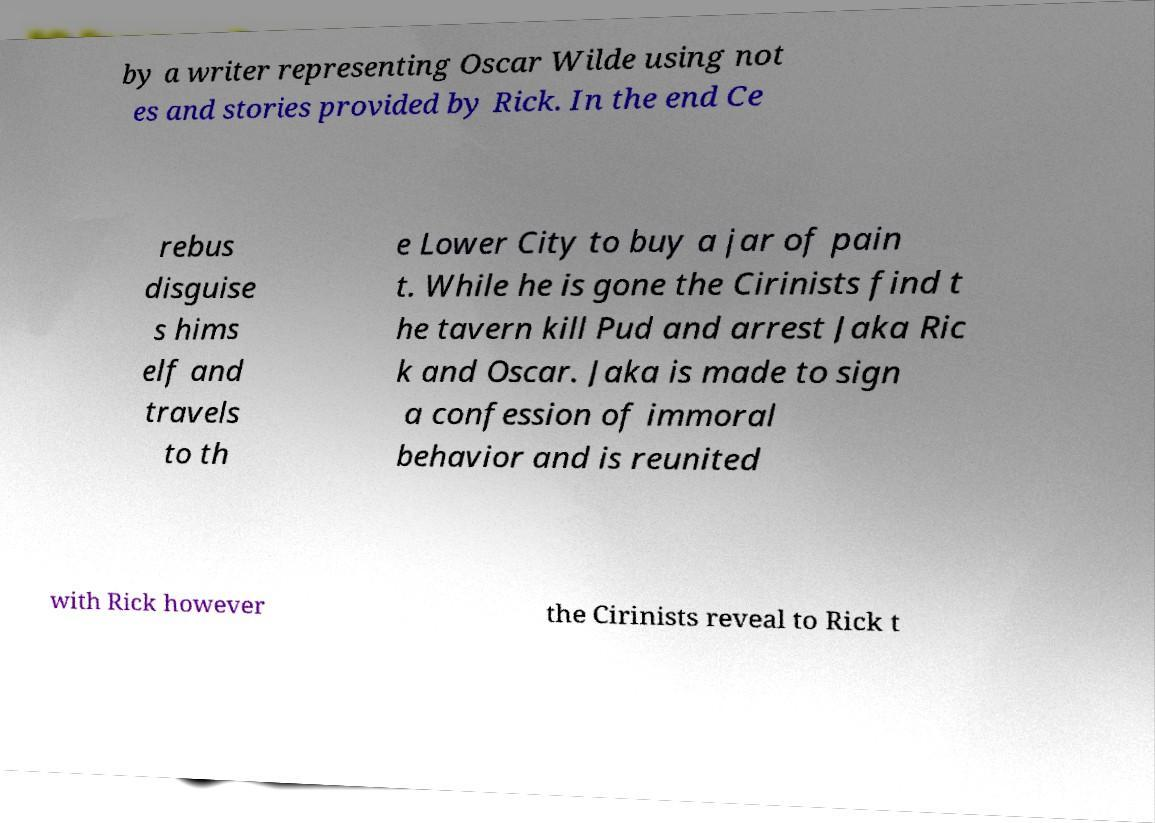Can you accurately transcribe the text from the provided image for me? by a writer representing Oscar Wilde using not es and stories provided by Rick. In the end Ce rebus disguise s hims elf and travels to th e Lower City to buy a jar of pain t. While he is gone the Cirinists find t he tavern kill Pud and arrest Jaka Ric k and Oscar. Jaka is made to sign a confession of immoral behavior and is reunited with Rick however the Cirinists reveal to Rick t 